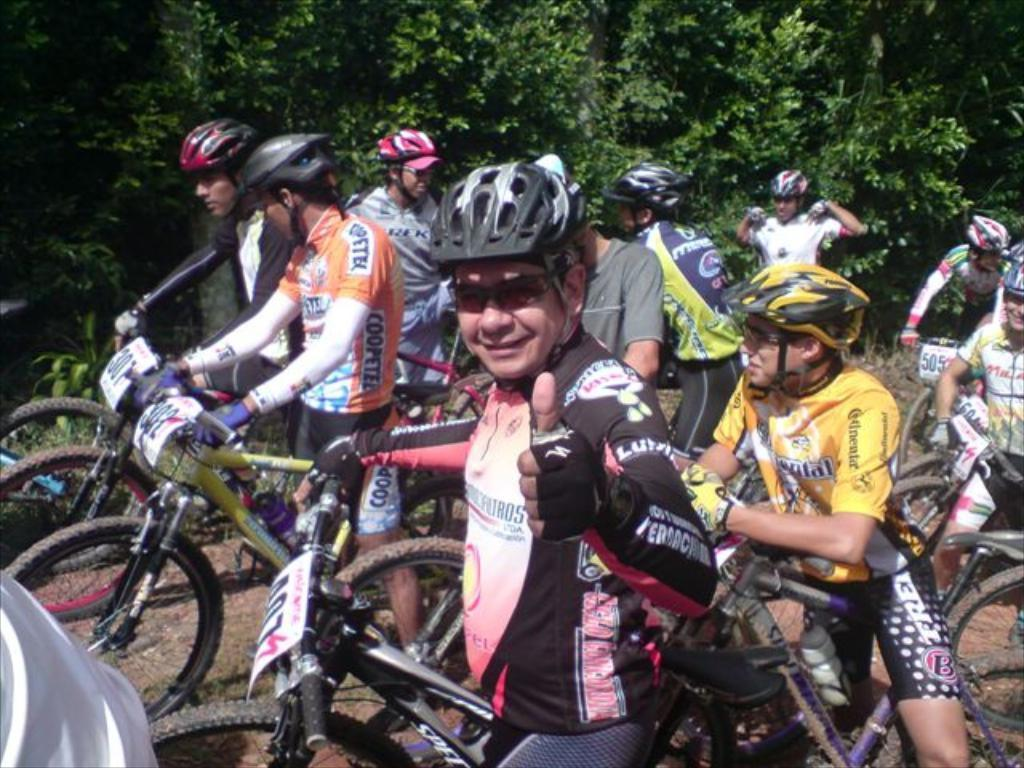Who is present in the image? There are people in the image. What are the people doing in the image? The people are with their cycles. What safety precaution are the people taking in the image? The people are wearing helmets. How many ants can be seen crawling on the feet of the people in the image? There are no ants present in the image, and therefore no ants can be seen crawling on the feet of the people. What part of the cycle is missing in the image? There is no indication that any part of the cycle is missing in the image; all cycles appear to be complete. 